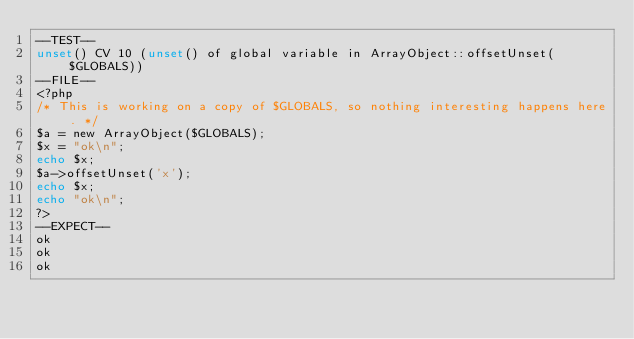Convert code to text. <code><loc_0><loc_0><loc_500><loc_500><_PHP_>--TEST--
unset() CV 10 (unset() of global variable in ArrayObject::offsetUnset($GLOBALS))
--FILE--
<?php
/* This is working on a copy of $GLOBALS, so nothing interesting happens here. */
$a = new ArrayObject($GLOBALS);
$x = "ok\n";
echo $x;
$a->offsetUnset('x');
echo $x;
echo "ok\n";
?>
--EXPECT--
ok
ok
ok
</code> 